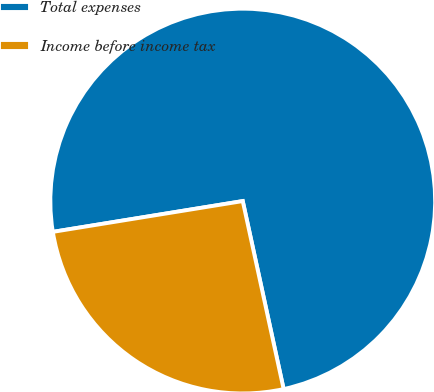<chart> <loc_0><loc_0><loc_500><loc_500><pie_chart><fcel>Total expenses<fcel>Income before income tax<nl><fcel>74.15%<fcel>25.85%<nl></chart> 